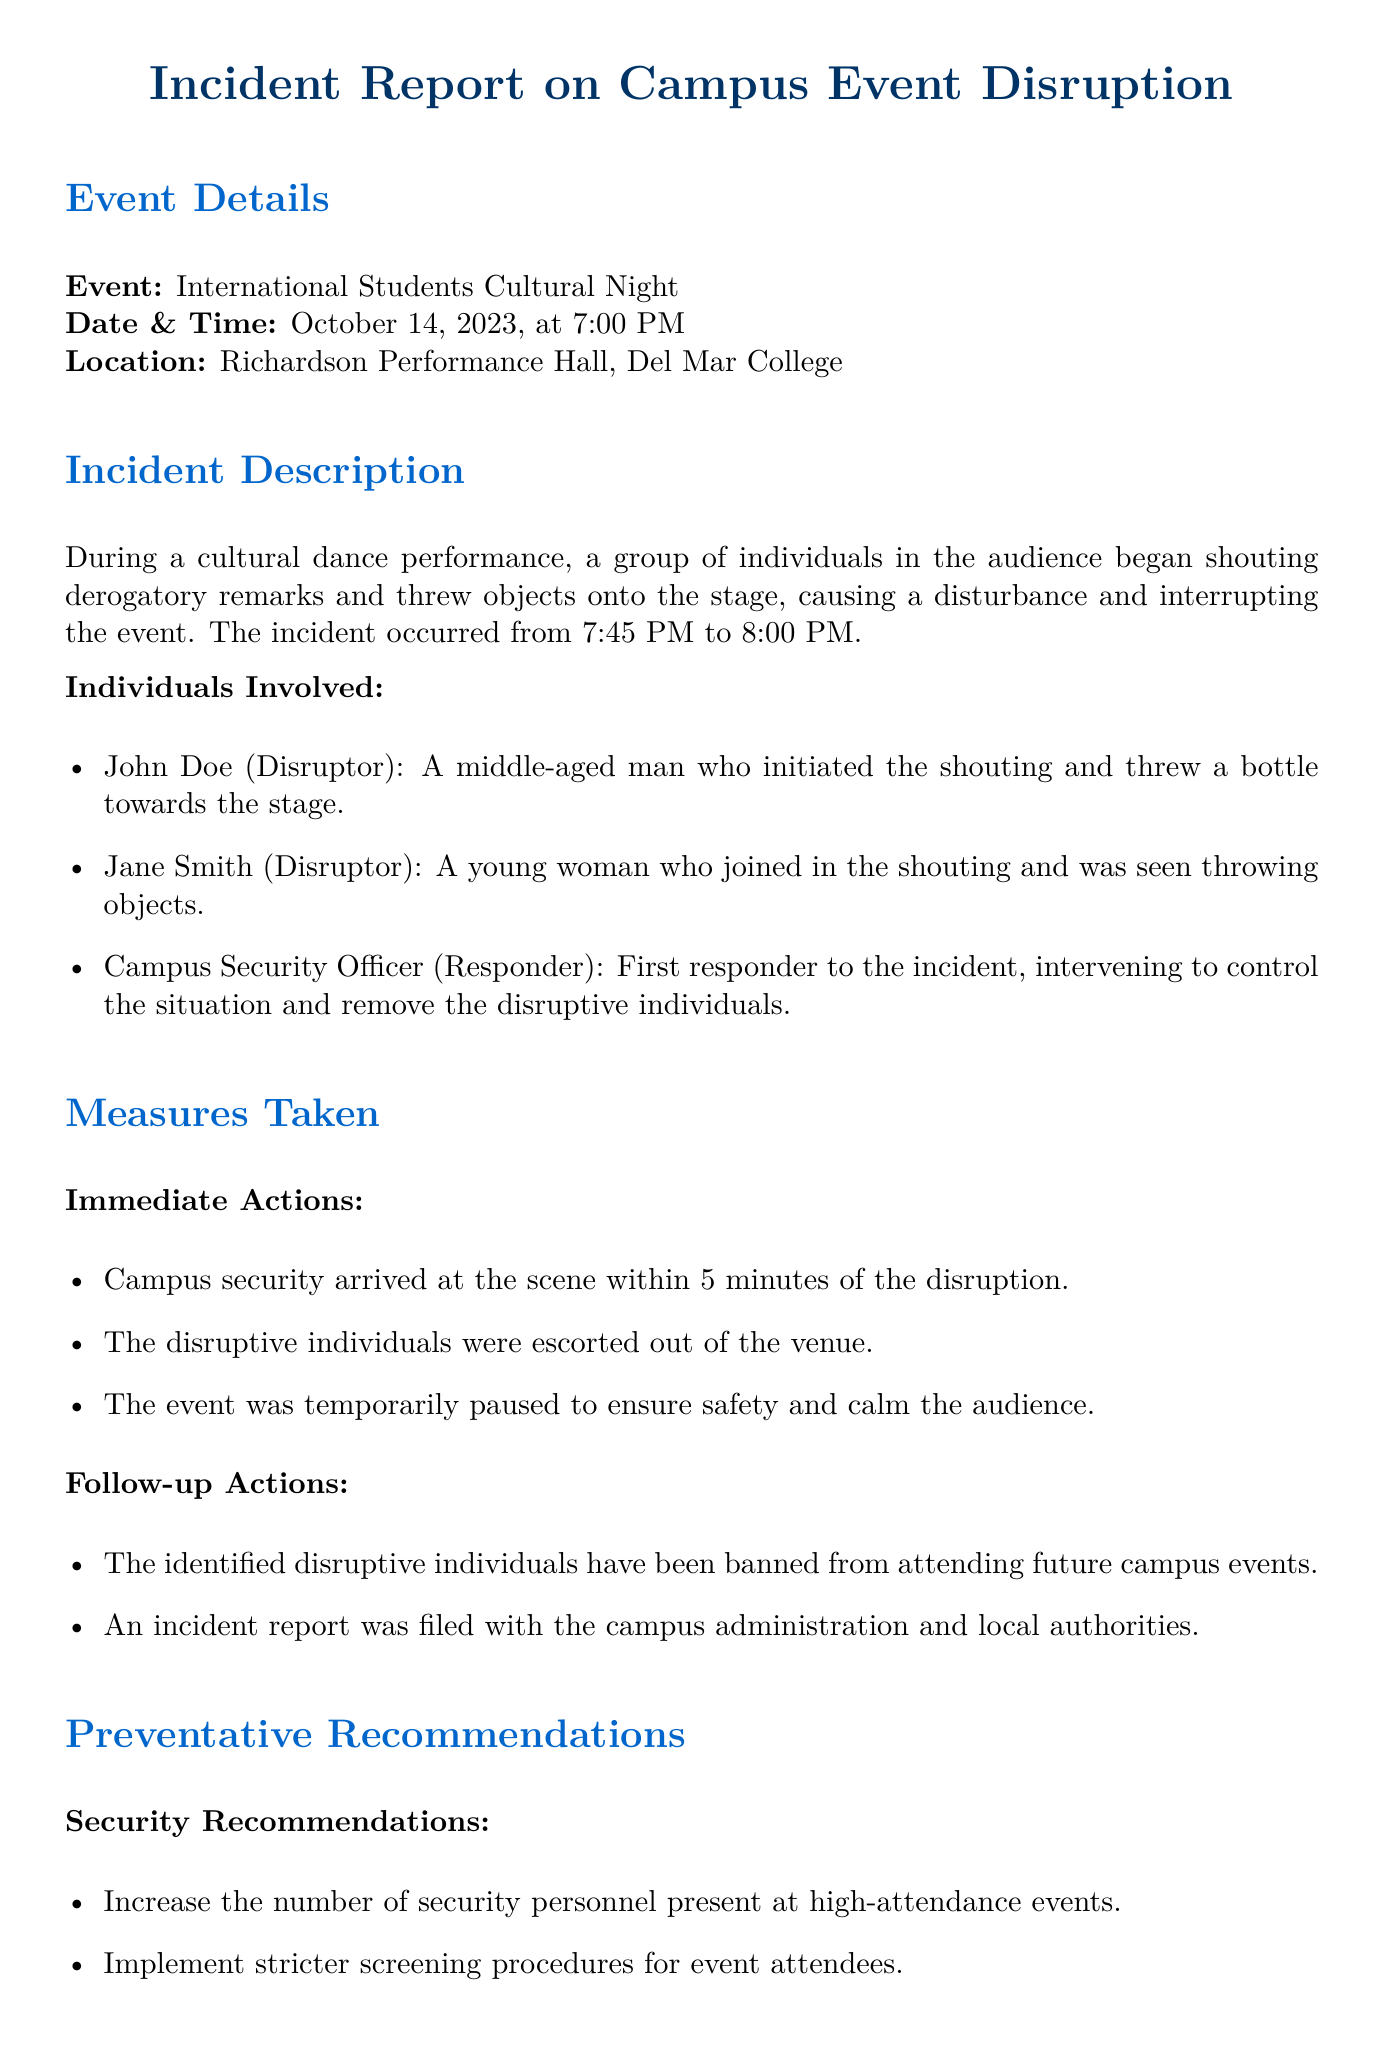What was the name of the event? The name of the event is explicitly stated in the document.
Answer: International Students Cultural Night When did the incident occur? The exact time frame of the incident is mentioned.
Answer: From 7:45 PM to 8:00 PM Who was the first respondent to the incident? The document lists individuals involved and identifies the responder.
Answer: Campus Security Officer What object did John Doe throw? The document specifies what John Doe threw during the incident.
Answer: A bottle What actions were taken to control the situation? The document outlines the immediate actions taken after the disruption.
Answer: Disruptive individuals were escorted out How long did it take for security to arrive? The time for security's arrival is mentioned as part of immediate actions.
Answer: 5 minutes What is one of the recommended security measures? The document contains recommendations for preventing future incidents.
Answer: Increase the number of security personnel What type of event was disrupted? The nature of the event is described at the beginning of the document.
Answer: Cultural night event What kind of workshops are recommended? The document suggests specific types of workshops for improvement.
Answer: Cultural sensitivity and awareness 